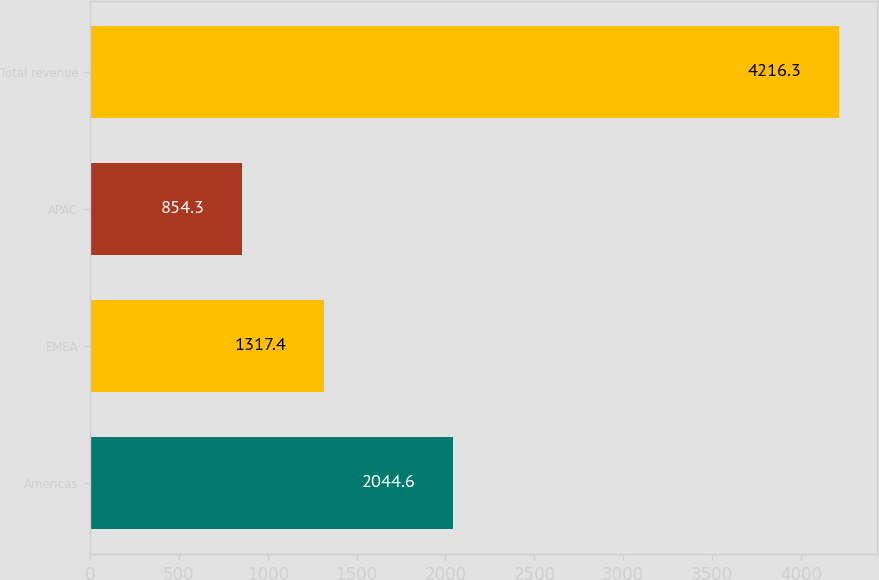Convert chart. <chart><loc_0><loc_0><loc_500><loc_500><bar_chart><fcel>Americas<fcel>EMEA<fcel>APAC<fcel>Total revenue<nl><fcel>2044.6<fcel>1317.4<fcel>854.3<fcel>4216.3<nl></chart> 